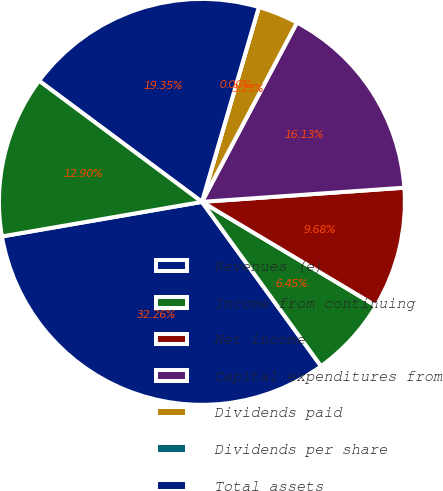<chart> <loc_0><loc_0><loc_500><loc_500><pie_chart><fcel>Revenues (e)<fcel>Income from continuing<fcel>Net income<fcel>Capital expenditures from<fcel>Dividends paid<fcel>Dividends per share<fcel>Total assets<fcel>Total long-term debt including<nl><fcel>32.26%<fcel>6.45%<fcel>9.68%<fcel>16.13%<fcel>3.23%<fcel>0.0%<fcel>19.35%<fcel>12.9%<nl></chart> 